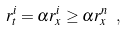<formula> <loc_0><loc_0><loc_500><loc_500>r _ { t } ^ { i } = \alpha r _ { x } ^ { i } \geq \alpha r _ { x } ^ { n } \ ,</formula> 